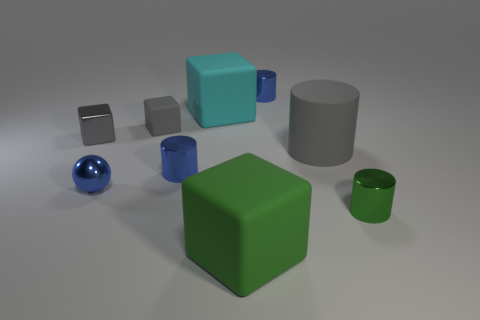Subtract 1 cylinders. How many cylinders are left? 3 Add 1 tiny gray rubber blocks. How many objects exist? 10 Subtract all cylinders. How many objects are left? 5 Subtract 0 cyan cylinders. How many objects are left? 9 Subtract all large brown cylinders. Subtract all gray rubber cylinders. How many objects are left? 8 Add 4 shiny spheres. How many shiny spheres are left? 5 Add 8 small red metallic balls. How many small red metallic balls exist? 8 